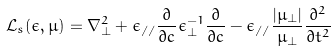Convert formula to latex. <formula><loc_0><loc_0><loc_500><loc_500>\mathcal { L } _ { s } ( \epsilon , \mu ) = \nabla _ { \perp } ^ { 2 } + \epsilon _ { / / } \frac { \partial } { \partial c } \epsilon _ { \perp } ^ { - 1 } \frac { \partial } { \partial c } - \epsilon _ { / / } \frac { \left | \mu _ { \perp } \right | } { \mu _ { \perp } } \frac { \partial ^ { 2 } } { \partial t ^ { 2 } }</formula> 